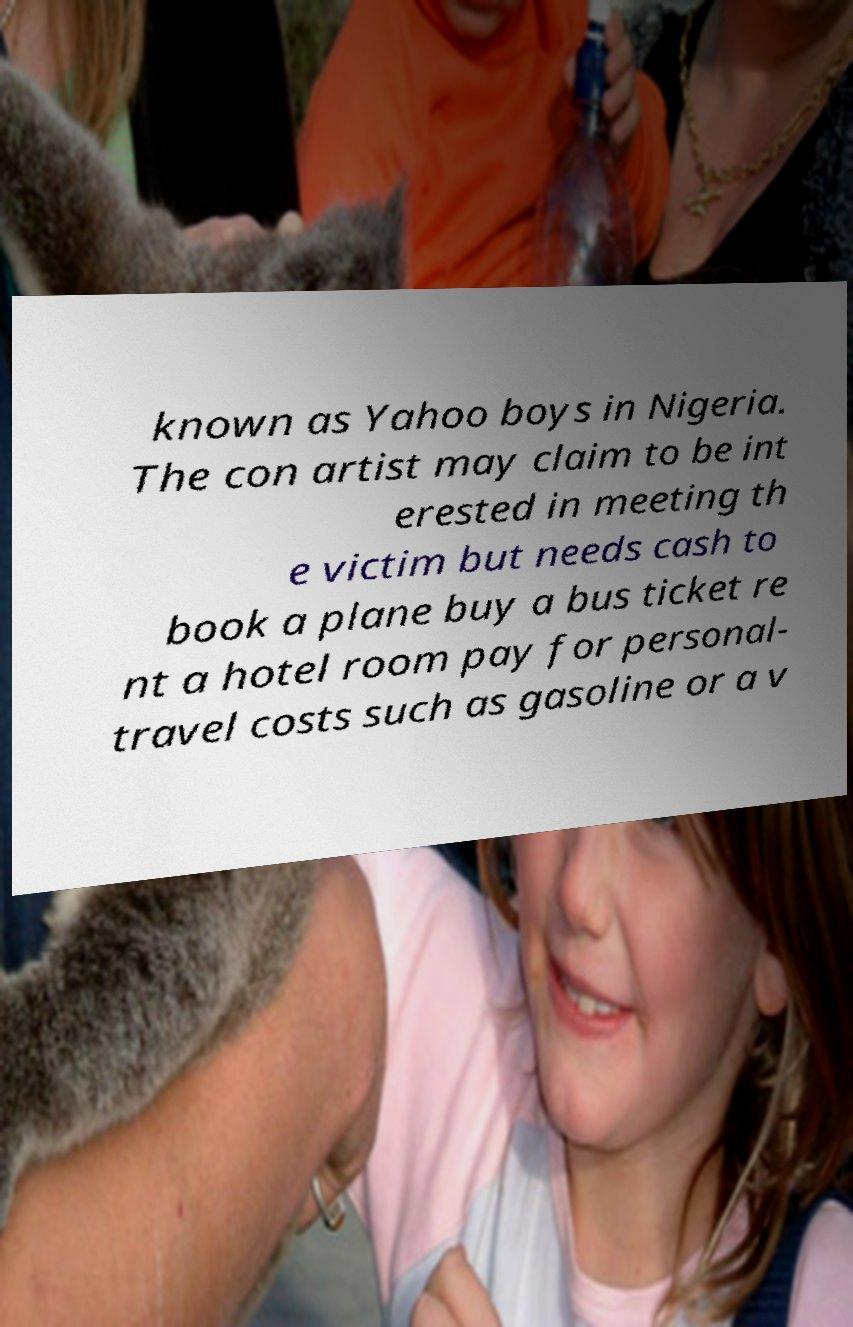What messages or text are displayed in this image? I need them in a readable, typed format. known as Yahoo boys in Nigeria. The con artist may claim to be int erested in meeting th e victim but needs cash to book a plane buy a bus ticket re nt a hotel room pay for personal- travel costs such as gasoline or a v 